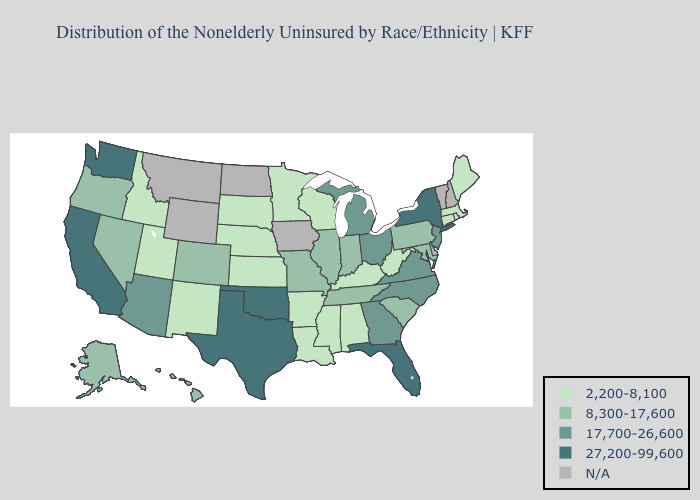What is the value of Mississippi?
Concise answer only. 2,200-8,100. What is the highest value in the USA?
Write a very short answer. 27,200-99,600. Name the states that have a value in the range 27,200-99,600?
Answer briefly. California, Florida, New York, Oklahoma, Texas, Washington. What is the lowest value in the MidWest?
Quick response, please. 2,200-8,100. Does Maine have the highest value in the USA?
Be succinct. No. What is the lowest value in the USA?
Quick response, please. 2,200-8,100. Name the states that have a value in the range 27,200-99,600?
Concise answer only. California, Florida, New York, Oklahoma, Texas, Washington. What is the value of Illinois?
Give a very brief answer. 8,300-17,600. Which states hav the highest value in the MidWest?
Short answer required. Michigan, Ohio. Does the map have missing data?
Short answer required. Yes. Does California have the highest value in the USA?
Concise answer only. Yes. How many symbols are there in the legend?
Quick response, please. 5. What is the lowest value in states that border Texas?
Be succinct. 2,200-8,100. What is the lowest value in states that border South Carolina?
Write a very short answer. 17,700-26,600. 